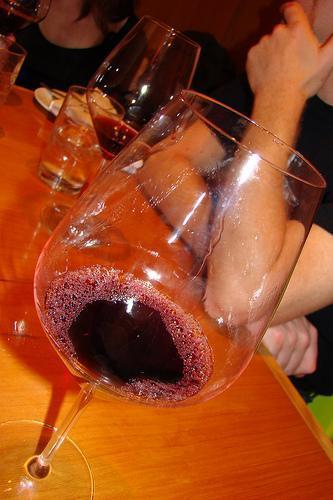How many people are in the picture?
Give a very brief answer. 2. 